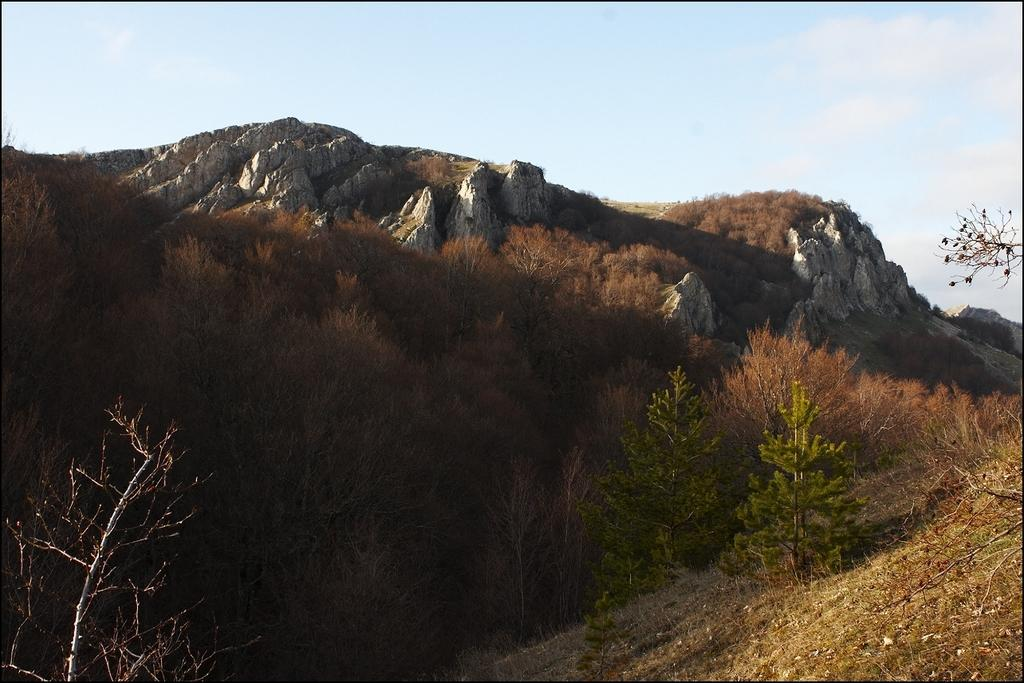What type of landscape feature is present in the image? There is a hill in the image. What is the condition of the grass around the hill? The grass around the hill is dry. Are there any plants visible in the image? Yes, there are trees in the image. What type of goose can be seen swimming in the basin near the hill? There is no goose or basin present in the image; it only features a hill and dry grass. Is there a carpenter working on the trees in the image? There is no carpenter or indication of any work being done on the trees in the image. 